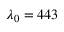<formula> <loc_0><loc_0><loc_500><loc_500>\lambda _ { 0 } = 4 4 3</formula> 